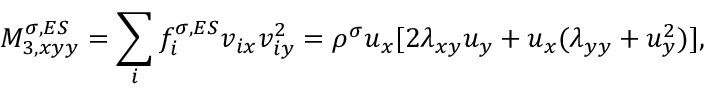<formula> <loc_0><loc_0><loc_500><loc_500>M _ { 3 , x y y } ^ { \sigma , E S } = \sum _ { i } f _ { i } ^ { \sigma , E S } v _ { i x } v _ { i y } ^ { 2 } = \rho ^ { \sigma } u _ { x } [ 2 \lambda _ { x y } u _ { y } + u _ { x } ( \lambda _ { y y } + u _ { y } ^ { 2 } ) ] ,</formula> 